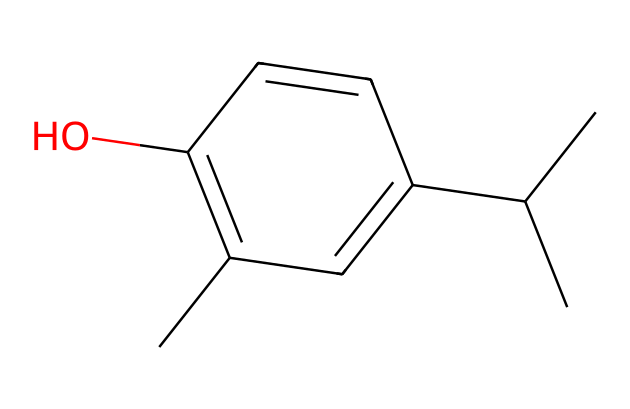How many carbon atoms are in this chemical? By examining the SMILES representation, each "C" character stands for a carbon atom. Counting all of them yields a total of 13 carbon atoms in the structure.
Answer: 13 What type of functional group is present in this chemical? The "(O)" in the structure indicates a hydroxyl group (-OH), which is a characteristic of alcohols. Therefore, this chemical contains a hydroxyl functional group.
Answer: hydroxyl How many double bonds are present in this molecule? In the structure, double bonds are represented by "=". By counting the "=" signs in the SMILES, we find that there are two double bonds in this molecule.
Answer: 2 What is the significance of the stereochemistry in this molecule? The structure implies possible stereochemistry around the double bonds and substituents. Stereochemistry can affect the molecule’s interactions and effectiveness as an antimicrobial agent.
Answer: interaction Does this molecule have a benzene ring? In the representation, the ring structure and alternating double bonds indicate a benzene ring is present. This can be recognized by looking for six carbons in a cyclic arrangement.
Answer: yes What role do the hydroxyl groups play in antimicrobial activity? Hydroxyl groups can enhance hydrogen bonding and help in solubilizing the molecule in water, which can contribute to the antimicrobial properties by increasing the interaction with microbial cell membranes.
Answer: enhance solubility 